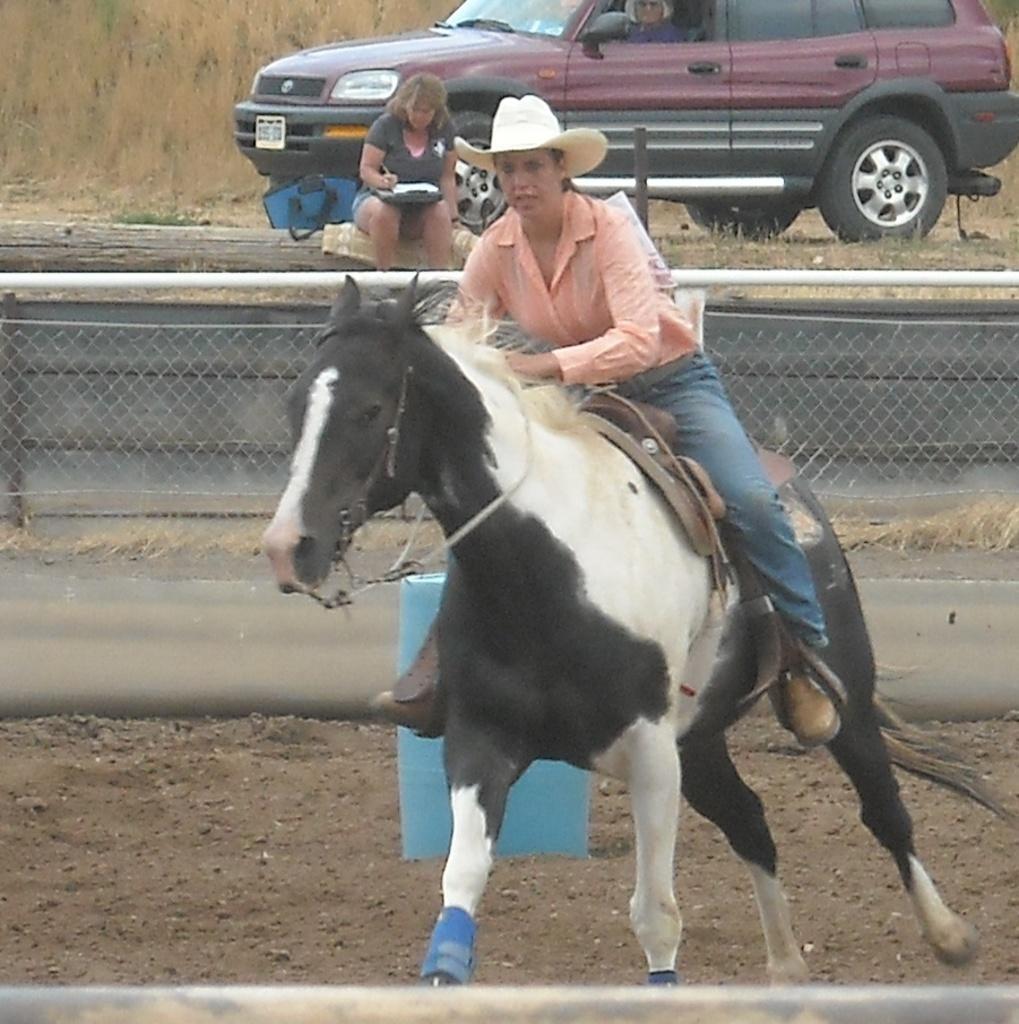In one or two sentences, can you explain what this image depicts? Women in pink shirt and blue jeans wearing white hat is riding horse. Beside her, we see a fence. Beside that, we see woman in black t-shirt is sitting on wood, is writing something on book and behind her, we see a car and beside that, we see grass. 